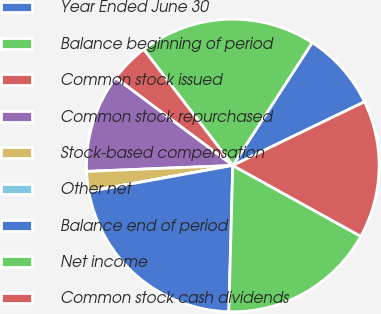<chart> <loc_0><loc_0><loc_500><loc_500><pie_chart><fcel>Year Ended June 30<fcel>Balance beginning of period<fcel>Common stock issued<fcel>Common stock repurchased<fcel>Stock-based compensation<fcel>Other net<fcel>Balance end of period<fcel>Net income<fcel>Common stock cash dividends<nl><fcel>8.7%<fcel>19.55%<fcel>4.36%<fcel>10.87%<fcel>2.19%<fcel>0.02%<fcel>21.72%<fcel>17.38%<fcel>15.21%<nl></chart> 